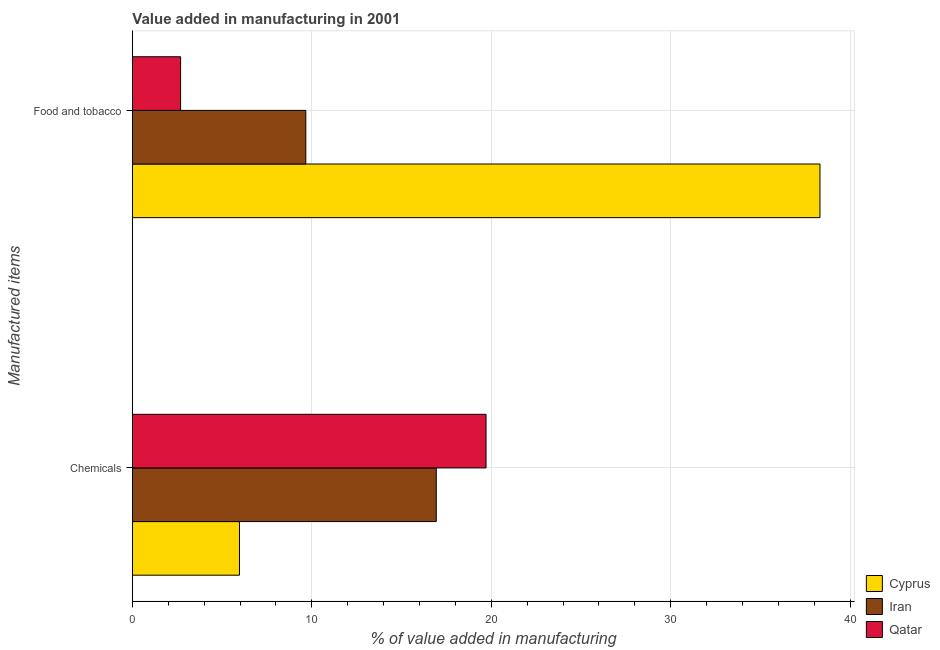Are the number of bars on each tick of the Y-axis equal?
Ensure brevity in your answer.  Yes. How many bars are there on the 1st tick from the top?
Your answer should be very brief. 3. What is the label of the 1st group of bars from the top?
Provide a succinct answer. Food and tobacco. What is the value added by manufacturing food and tobacco in Qatar?
Make the answer very short. 2.69. Across all countries, what is the maximum value added by  manufacturing chemicals?
Give a very brief answer. 19.71. Across all countries, what is the minimum value added by  manufacturing chemicals?
Keep it short and to the point. 5.97. In which country was the value added by  manufacturing chemicals maximum?
Offer a very short reply. Qatar. In which country was the value added by manufacturing food and tobacco minimum?
Provide a short and direct response. Qatar. What is the total value added by manufacturing food and tobacco in the graph?
Ensure brevity in your answer.  50.67. What is the difference between the value added by manufacturing food and tobacco in Qatar and that in Cyprus?
Your response must be concise. -35.64. What is the difference between the value added by  manufacturing chemicals in Cyprus and the value added by manufacturing food and tobacco in Iran?
Your response must be concise. -3.7. What is the average value added by  manufacturing chemicals per country?
Provide a succinct answer. 14.2. What is the difference between the value added by manufacturing food and tobacco and value added by  manufacturing chemicals in Cyprus?
Your answer should be very brief. 32.36. In how many countries, is the value added by  manufacturing chemicals greater than 8 %?
Your response must be concise. 2. What is the ratio of the value added by  manufacturing chemicals in Cyprus to that in Iran?
Offer a terse response. 0.35. Is the value added by manufacturing food and tobacco in Cyprus less than that in Qatar?
Ensure brevity in your answer.  No. What does the 1st bar from the top in Chemicals represents?
Give a very brief answer. Qatar. What does the 2nd bar from the bottom in Food and tobacco represents?
Make the answer very short. Iran. Are the values on the major ticks of X-axis written in scientific E-notation?
Ensure brevity in your answer.  No. Does the graph contain any zero values?
Provide a succinct answer. No. Where does the legend appear in the graph?
Your response must be concise. Bottom right. What is the title of the graph?
Make the answer very short. Value added in manufacturing in 2001. Does "Singapore" appear as one of the legend labels in the graph?
Give a very brief answer. No. What is the label or title of the X-axis?
Offer a very short reply. % of value added in manufacturing. What is the label or title of the Y-axis?
Offer a very short reply. Manufactured items. What is the % of value added in manufacturing of Cyprus in Chemicals?
Ensure brevity in your answer.  5.97. What is the % of value added in manufacturing of Iran in Chemicals?
Make the answer very short. 16.94. What is the % of value added in manufacturing in Qatar in Chemicals?
Your answer should be compact. 19.71. What is the % of value added in manufacturing of Cyprus in Food and tobacco?
Keep it short and to the point. 38.32. What is the % of value added in manufacturing of Iran in Food and tobacco?
Offer a terse response. 9.66. What is the % of value added in manufacturing of Qatar in Food and tobacco?
Ensure brevity in your answer.  2.69. Across all Manufactured items, what is the maximum % of value added in manufacturing of Cyprus?
Make the answer very short. 38.32. Across all Manufactured items, what is the maximum % of value added in manufacturing of Iran?
Provide a short and direct response. 16.94. Across all Manufactured items, what is the maximum % of value added in manufacturing in Qatar?
Ensure brevity in your answer.  19.71. Across all Manufactured items, what is the minimum % of value added in manufacturing of Cyprus?
Give a very brief answer. 5.97. Across all Manufactured items, what is the minimum % of value added in manufacturing of Iran?
Provide a short and direct response. 9.66. Across all Manufactured items, what is the minimum % of value added in manufacturing of Qatar?
Ensure brevity in your answer.  2.69. What is the total % of value added in manufacturing of Cyprus in the graph?
Provide a succinct answer. 44.29. What is the total % of value added in manufacturing in Iran in the graph?
Offer a terse response. 26.6. What is the total % of value added in manufacturing in Qatar in the graph?
Provide a succinct answer. 22.4. What is the difference between the % of value added in manufacturing of Cyprus in Chemicals and that in Food and tobacco?
Ensure brevity in your answer.  -32.36. What is the difference between the % of value added in manufacturing in Iran in Chemicals and that in Food and tobacco?
Offer a terse response. 7.27. What is the difference between the % of value added in manufacturing of Qatar in Chemicals and that in Food and tobacco?
Provide a succinct answer. 17.03. What is the difference between the % of value added in manufacturing in Cyprus in Chemicals and the % of value added in manufacturing in Iran in Food and tobacco?
Give a very brief answer. -3.7. What is the difference between the % of value added in manufacturing in Cyprus in Chemicals and the % of value added in manufacturing in Qatar in Food and tobacco?
Your answer should be very brief. 3.28. What is the difference between the % of value added in manufacturing in Iran in Chemicals and the % of value added in manufacturing in Qatar in Food and tobacco?
Your answer should be very brief. 14.25. What is the average % of value added in manufacturing in Cyprus per Manufactured items?
Keep it short and to the point. 22.14. What is the average % of value added in manufacturing of Iran per Manufactured items?
Provide a short and direct response. 13.3. What is the average % of value added in manufacturing in Qatar per Manufactured items?
Offer a very short reply. 11.2. What is the difference between the % of value added in manufacturing of Cyprus and % of value added in manufacturing of Iran in Chemicals?
Ensure brevity in your answer.  -10.97. What is the difference between the % of value added in manufacturing in Cyprus and % of value added in manufacturing in Qatar in Chemicals?
Your answer should be compact. -13.74. What is the difference between the % of value added in manufacturing in Iran and % of value added in manufacturing in Qatar in Chemicals?
Give a very brief answer. -2.77. What is the difference between the % of value added in manufacturing in Cyprus and % of value added in manufacturing in Iran in Food and tobacco?
Keep it short and to the point. 28.66. What is the difference between the % of value added in manufacturing in Cyprus and % of value added in manufacturing in Qatar in Food and tobacco?
Offer a terse response. 35.64. What is the difference between the % of value added in manufacturing in Iran and % of value added in manufacturing in Qatar in Food and tobacco?
Your answer should be very brief. 6.98. What is the ratio of the % of value added in manufacturing of Cyprus in Chemicals to that in Food and tobacco?
Give a very brief answer. 0.16. What is the ratio of the % of value added in manufacturing of Iran in Chemicals to that in Food and tobacco?
Your response must be concise. 1.75. What is the ratio of the % of value added in manufacturing in Qatar in Chemicals to that in Food and tobacco?
Provide a short and direct response. 7.34. What is the difference between the highest and the second highest % of value added in manufacturing of Cyprus?
Offer a terse response. 32.36. What is the difference between the highest and the second highest % of value added in manufacturing of Iran?
Keep it short and to the point. 7.27. What is the difference between the highest and the second highest % of value added in manufacturing of Qatar?
Your response must be concise. 17.03. What is the difference between the highest and the lowest % of value added in manufacturing of Cyprus?
Provide a short and direct response. 32.36. What is the difference between the highest and the lowest % of value added in manufacturing in Iran?
Make the answer very short. 7.27. What is the difference between the highest and the lowest % of value added in manufacturing in Qatar?
Offer a terse response. 17.03. 